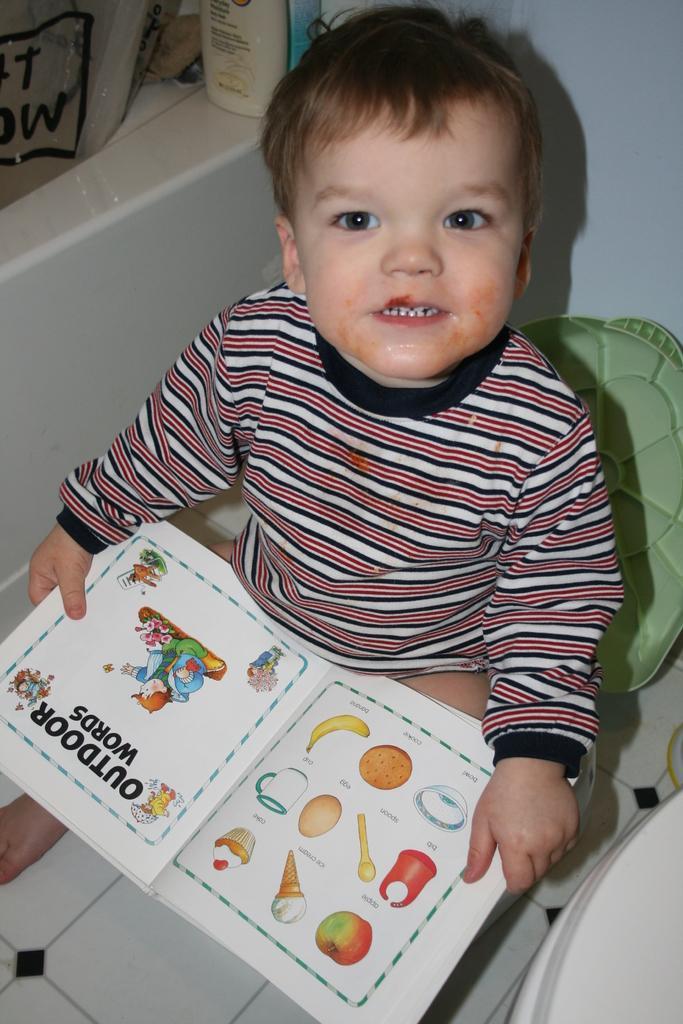Could you give a brief overview of what you see in this image? This kid is holding a book and looking upwards. Beside this kid there is a bottle and things. This is white wall. 